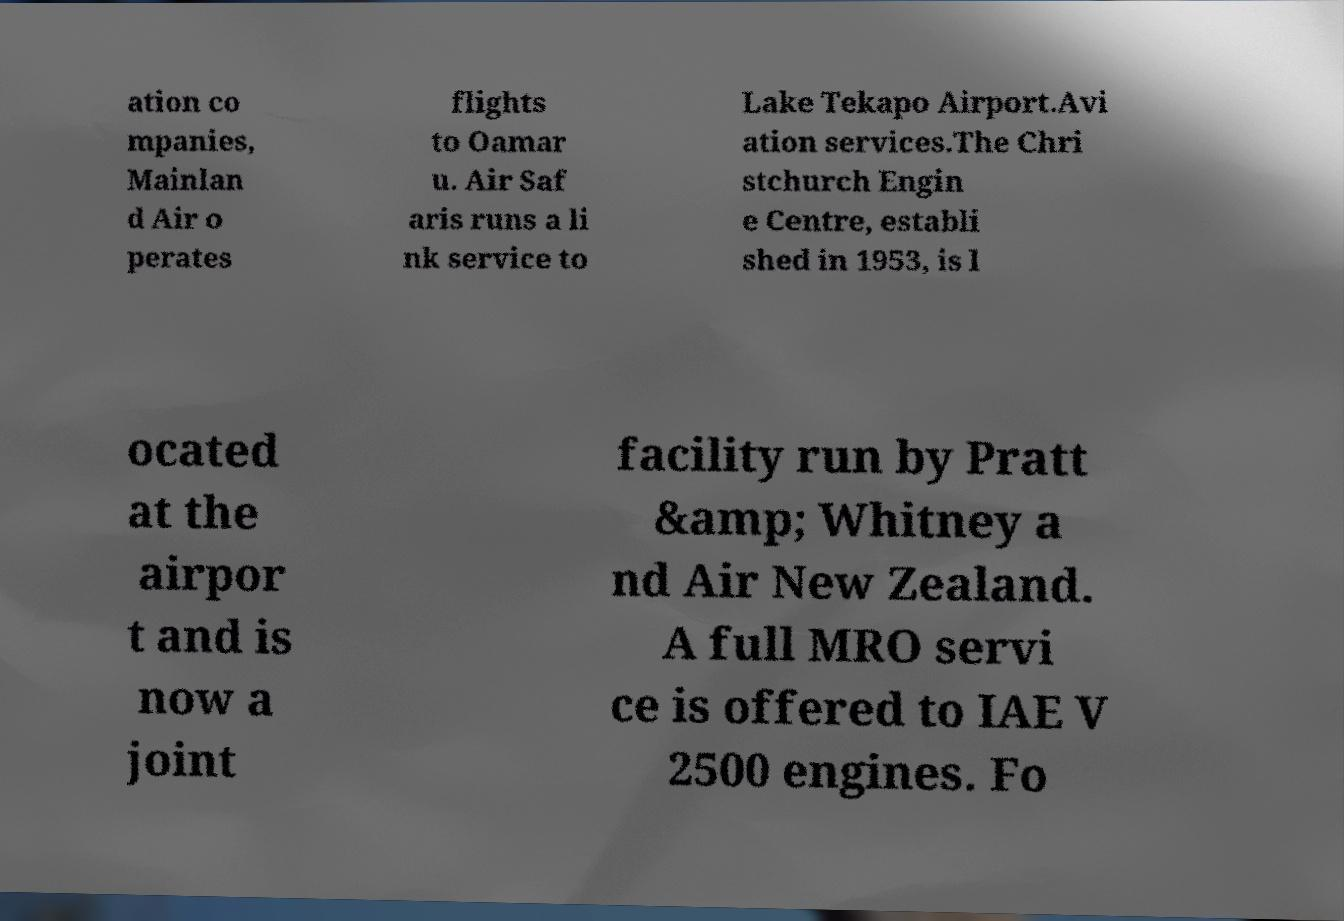Could you extract and type out the text from this image? ation co mpanies, Mainlan d Air o perates flights to Oamar u. Air Saf aris runs a li nk service to Lake Tekapo Airport.Avi ation services.The Chri stchurch Engin e Centre, establi shed in 1953, is l ocated at the airpor t and is now a joint facility run by Pratt &amp; Whitney a nd Air New Zealand. A full MRO servi ce is offered to IAE V 2500 engines. Fo 